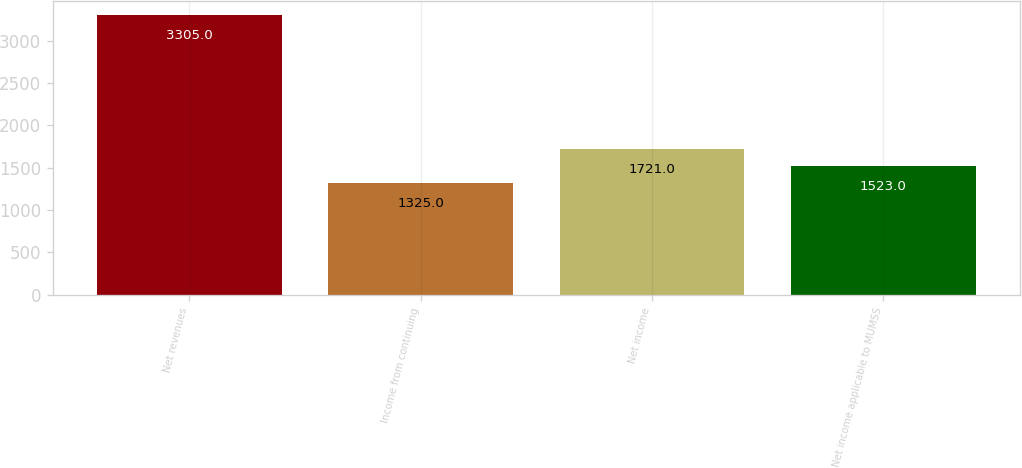Convert chart. <chart><loc_0><loc_0><loc_500><loc_500><bar_chart><fcel>Net revenues<fcel>Income from continuing<fcel>Net income<fcel>Net income applicable to MUMSS<nl><fcel>3305<fcel>1325<fcel>1721<fcel>1523<nl></chart> 